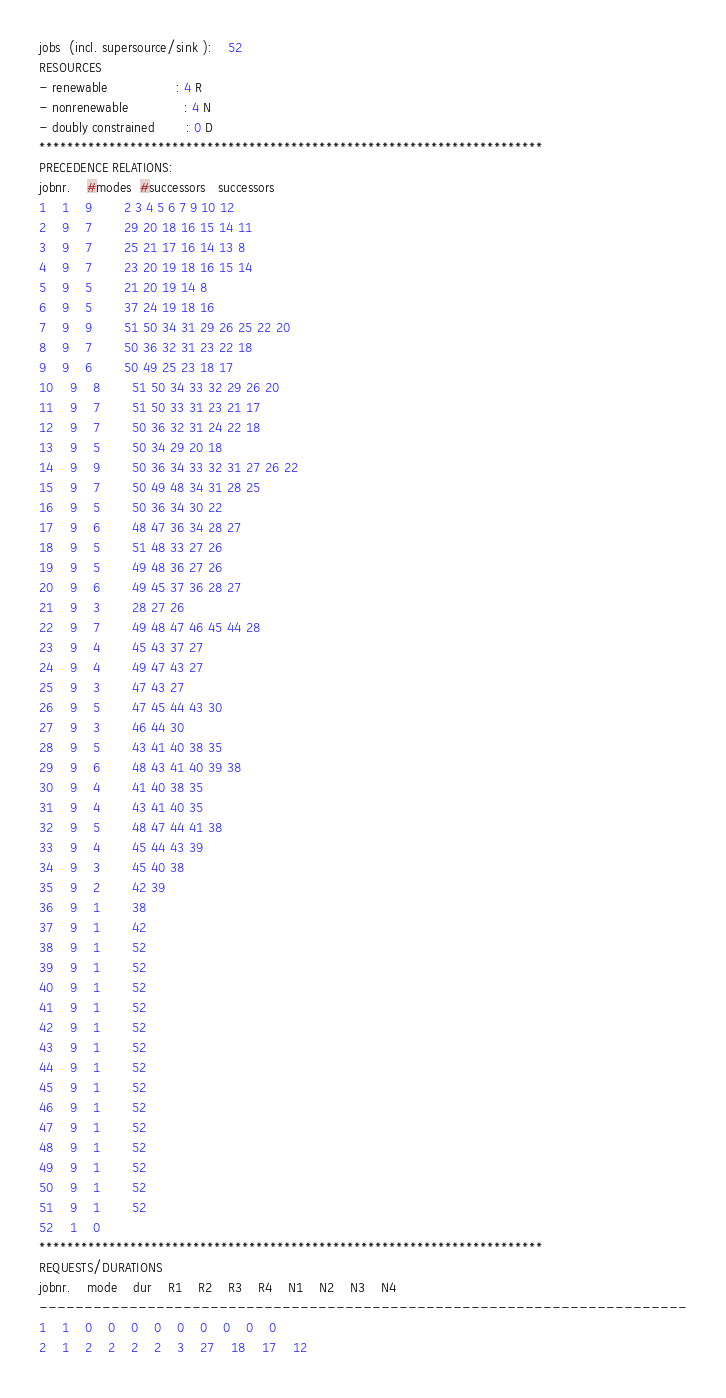<code> <loc_0><loc_0><loc_500><loc_500><_ObjectiveC_>jobs  (incl. supersource/sink ):	52
RESOURCES
- renewable                 : 4 R
- nonrenewable              : 4 N
- doubly constrained        : 0 D
************************************************************************
PRECEDENCE RELATIONS:
jobnr.    #modes  #successors   successors
1	1	9		2 3 4 5 6 7 9 10 12 
2	9	7		29 20 18 16 15 14 11 
3	9	7		25 21 17 16 14 13 8 
4	9	7		23 20 19 18 16 15 14 
5	9	5		21 20 19 14 8 
6	9	5		37 24 19 18 16 
7	9	9		51 50 34 31 29 26 25 22 20 
8	9	7		50 36 32 31 23 22 18 
9	9	6		50 49 25 23 18 17 
10	9	8		51 50 34 33 32 29 26 20 
11	9	7		51 50 33 31 23 21 17 
12	9	7		50 36 32 31 24 22 18 
13	9	5		50 34 29 20 18 
14	9	9		50 36 34 33 32 31 27 26 22 
15	9	7		50 49 48 34 31 28 25 
16	9	5		50 36 34 30 22 
17	9	6		48 47 36 34 28 27 
18	9	5		51 48 33 27 26 
19	9	5		49 48 36 27 26 
20	9	6		49 45 37 36 28 27 
21	9	3		28 27 26 
22	9	7		49 48 47 46 45 44 28 
23	9	4		45 43 37 27 
24	9	4		49 47 43 27 
25	9	3		47 43 27 
26	9	5		47 45 44 43 30 
27	9	3		46 44 30 
28	9	5		43 41 40 38 35 
29	9	6		48 43 41 40 39 38 
30	9	4		41 40 38 35 
31	9	4		43 41 40 35 
32	9	5		48 47 44 41 38 
33	9	4		45 44 43 39 
34	9	3		45 40 38 
35	9	2		42 39 
36	9	1		38 
37	9	1		42 
38	9	1		52 
39	9	1		52 
40	9	1		52 
41	9	1		52 
42	9	1		52 
43	9	1		52 
44	9	1		52 
45	9	1		52 
46	9	1		52 
47	9	1		52 
48	9	1		52 
49	9	1		52 
50	9	1		52 
51	9	1		52 
52	1	0		
************************************************************************
REQUESTS/DURATIONS
jobnr.	mode	dur	R1	R2	R3	R4	N1	N2	N3	N4	
------------------------------------------------------------------------
1	1	0	0	0	0	0	0	0	0	0	
2	1	2	2	2	2	3	27	18	17	12	</code> 